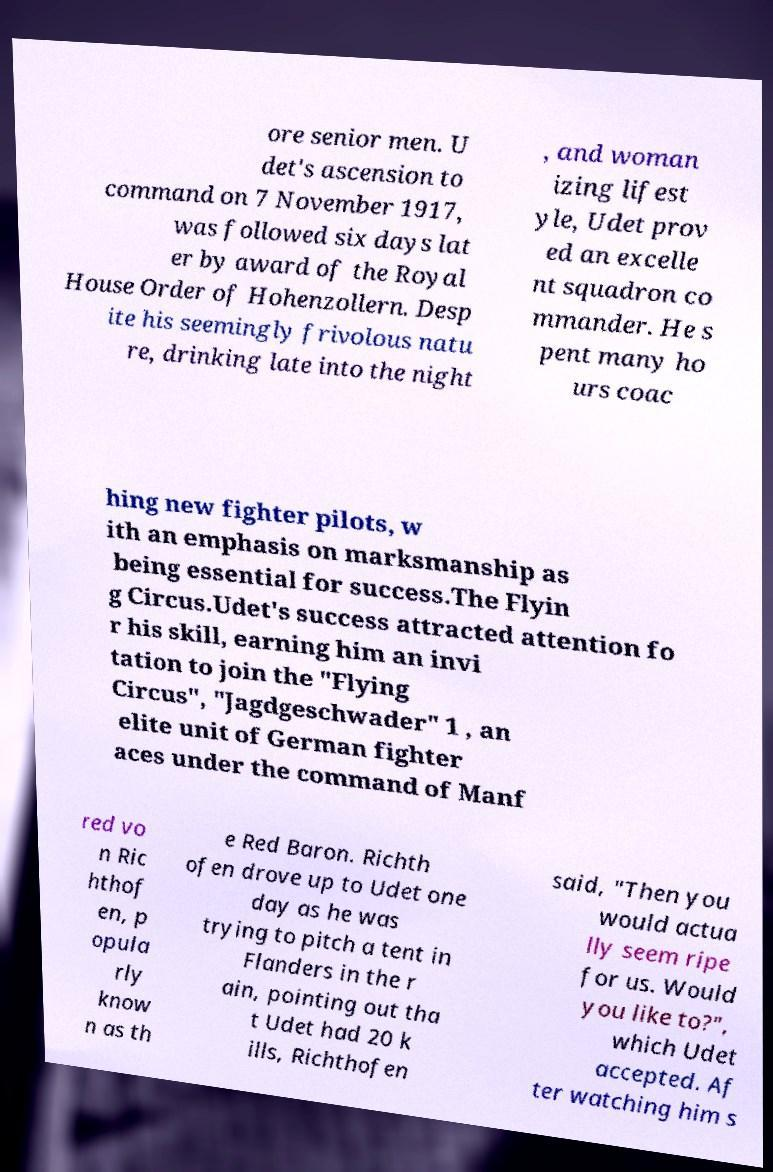Could you extract and type out the text from this image? ore senior men. U det's ascension to command on 7 November 1917, was followed six days lat er by award of the Royal House Order of Hohenzollern. Desp ite his seemingly frivolous natu re, drinking late into the night , and woman izing lifest yle, Udet prov ed an excelle nt squadron co mmander. He s pent many ho urs coac hing new fighter pilots, w ith an emphasis on marksmanship as being essential for success.The Flyin g Circus.Udet's success attracted attention fo r his skill, earning him an invi tation to join the "Flying Circus", "Jagdgeschwader" 1 , an elite unit of German fighter aces under the command of Manf red vo n Ric hthof en, p opula rly know n as th e Red Baron. Richth ofen drove up to Udet one day as he was trying to pitch a tent in Flanders in the r ain, pointing out tha t Udet had 20 k ills, Richthofen said, "Then you would actua lly seem ripe for us. Would you like to?", which Udet accepted. Af ter watching him s 